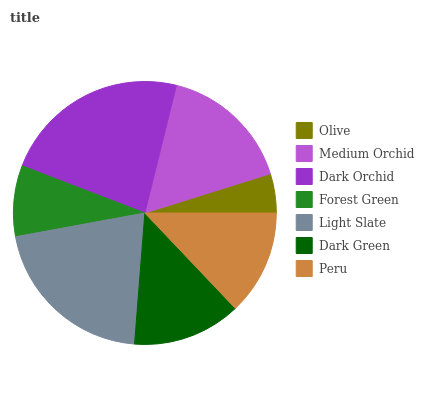Is Olive the minimum?
Answer yes or no. Yes. Is Dark Orchid the maximum?
Answer yes or no. Yes. Is Medium Orchid the minimum?
Answer yes or no. No. Is Medium Orchid the maximum?
Answer yes or no. No. Is Medium Orchid greater than Olive?
Answer yes or no. Yes. Is Olive less than Medium Orchid?
Answer yes or no. Yes. Is Olive greater than Medium Orchid?
Answer yes or no. No. Is Medium Orchid less than Olive?
Answer yes or no. No. Is Dark Green the high median?
Answer yes or no. Yes. Is Dark Green the low median?
Answer yes or no. Yes. Is Forest Green the high median?
Answer yes or no. No. Is Dark Orchid the low median?
Answer yes or no. No. 